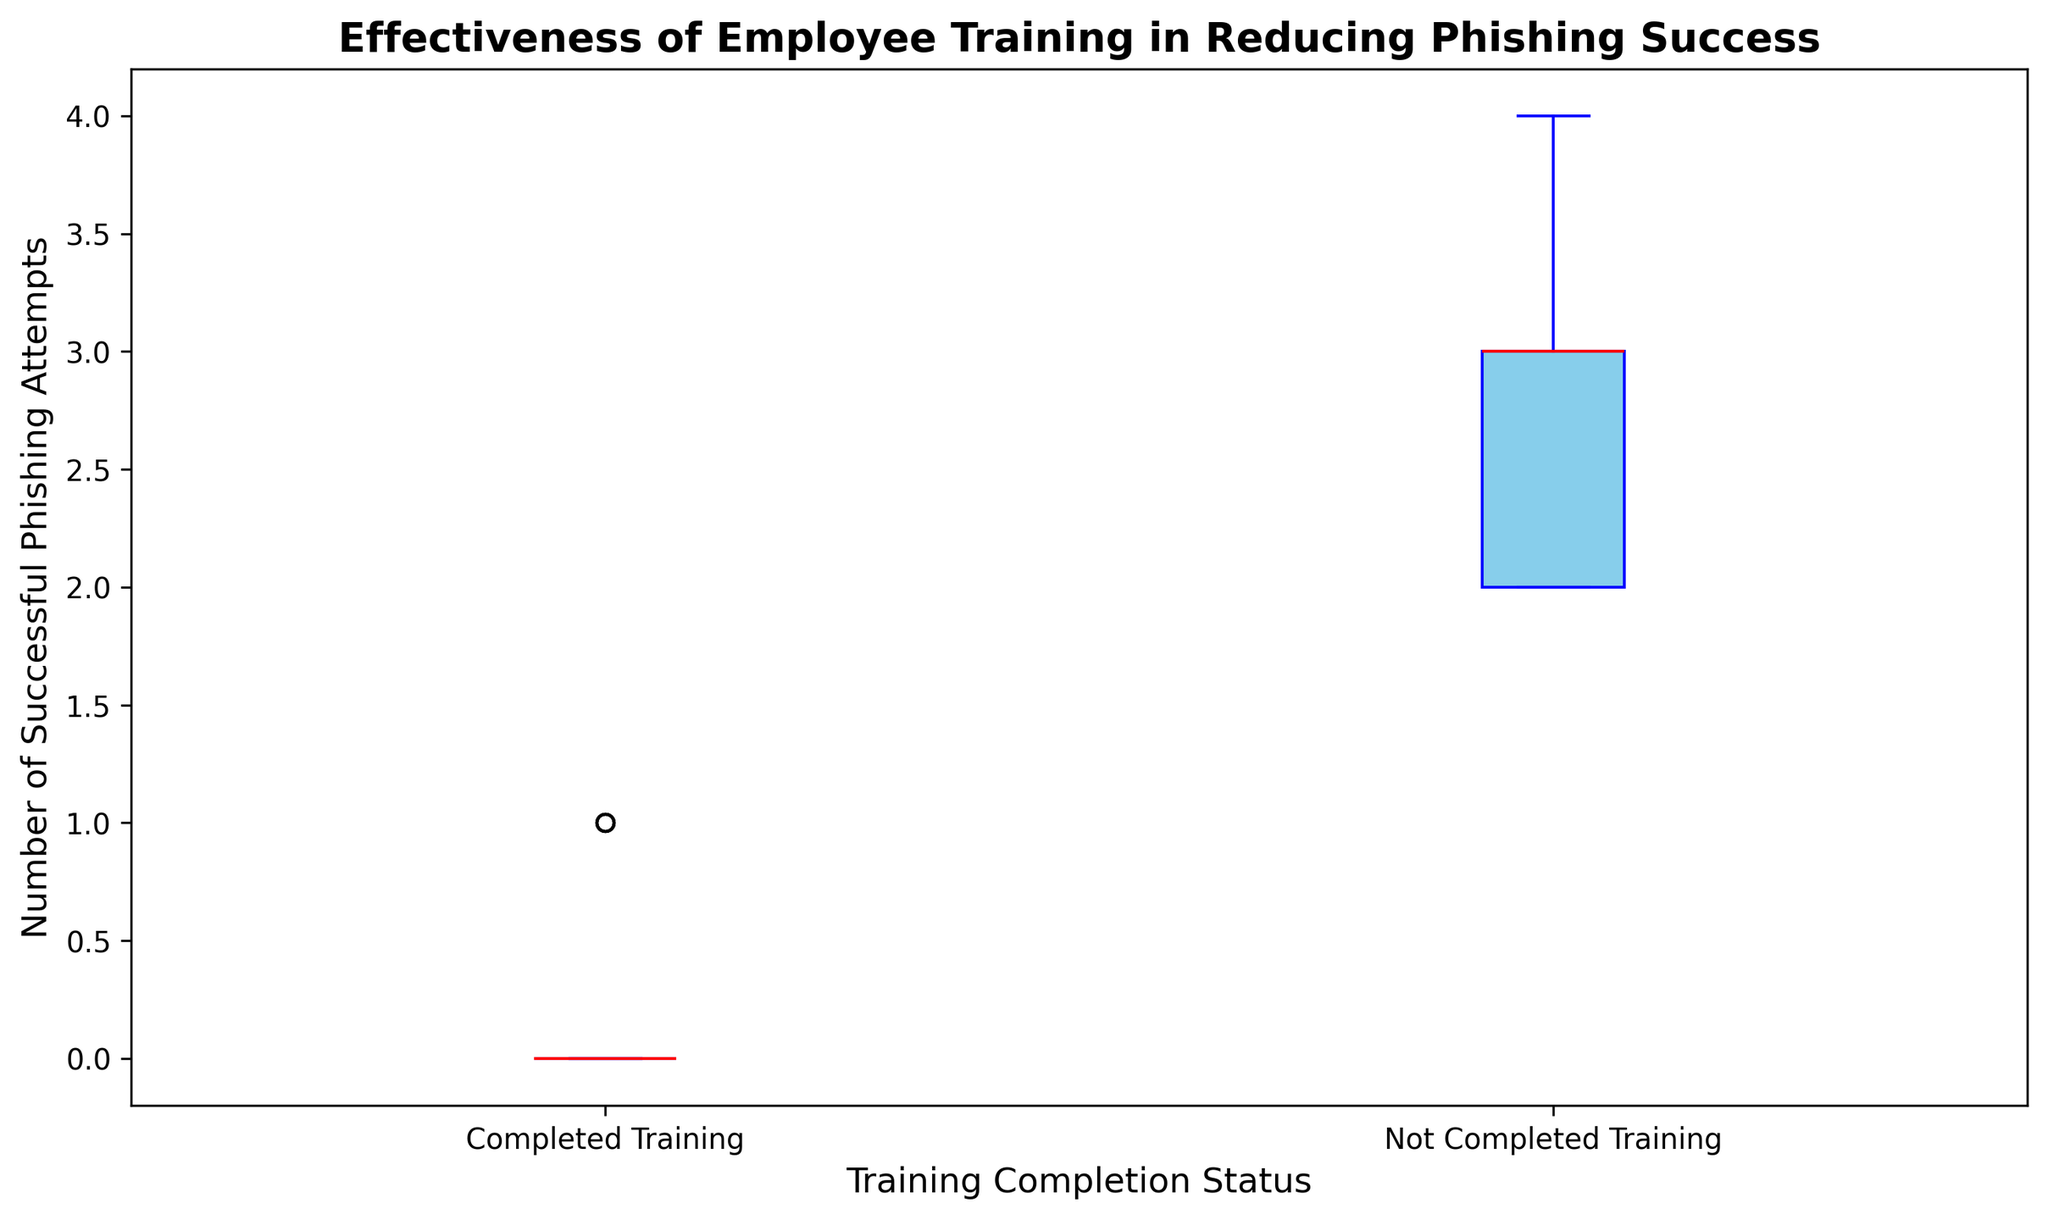What is the median number of successful phishing attempts for employees who completed the training? Look at the box labeled 'Completed Training'. The red line in the middle of this box represents the median.
Answer: 0 What is the median number of successful phishing attempts for employees who did not complete the training? Look at the box labeled 'Not Completed Training'. The red line in the middle of this box represents the median.
Answer: 3 How do the median successful phishing attempts compare between those who completed and did not complete the training? Compare the red lines in both boxes. The median for 'Completed Training' is much lower (0) than 'Not Completed Training' (3). This suggests a significant difference in phishing success rates between the two groups.
Answer: The median for completed training is lower at 0 What is the interquartile range (IQR) for the 'Not Completed Training' group? The IQR is the difference between the third quartile (Q3) and the first quartile (Q1). The top and bottom edges of the blue-colored box represent Q3 and Q1, respectively. Estimate these values and subtract Q1 from Q3. Let's denote Q3 as 4 and Q1 as 2.
Answer: 2 Which group has more variability in their data, those who completed the training or those who did not? Look at the lengths of the boxes and the whiskers. The 'Not Completed Training' group has a taller box and longer whiskers, indicating more variability.
Answer: Not completed training Is there any overlap in the range of successful phishing attempts between the two groups? Compare the whiskers of both boxes. If they touch or overlap, there is an overlap in the range. The highest value in the 'Completed Training' group is close to the lowest value in the 'Not Completed Training' group, indicating a minimal overlap.
Answer: Minimal overlap What is the maximum number of successful phishing attempts for employees who did not complete the training? Look at the topmost part of the whisker for the 'Not Completed Training' box. This represents the maximum value.
Answer: 4 Which group has outliers, if any, and how are they represented visually? Look for individual points outside the whiskers. There are no individual points outside the whiskers, indicating no outliers in either group.
Answer: No group has outliers What can be inferred about the effectiveness of the training in combating phishing attempts? Compare the medians and the spread of the whiskers and boxes. The 'Completed Training' group shows a significantly lower median and less variability in successful phishing attempts, indicating that the training is effective in reducing phishing success.
Answer: Training is effective 